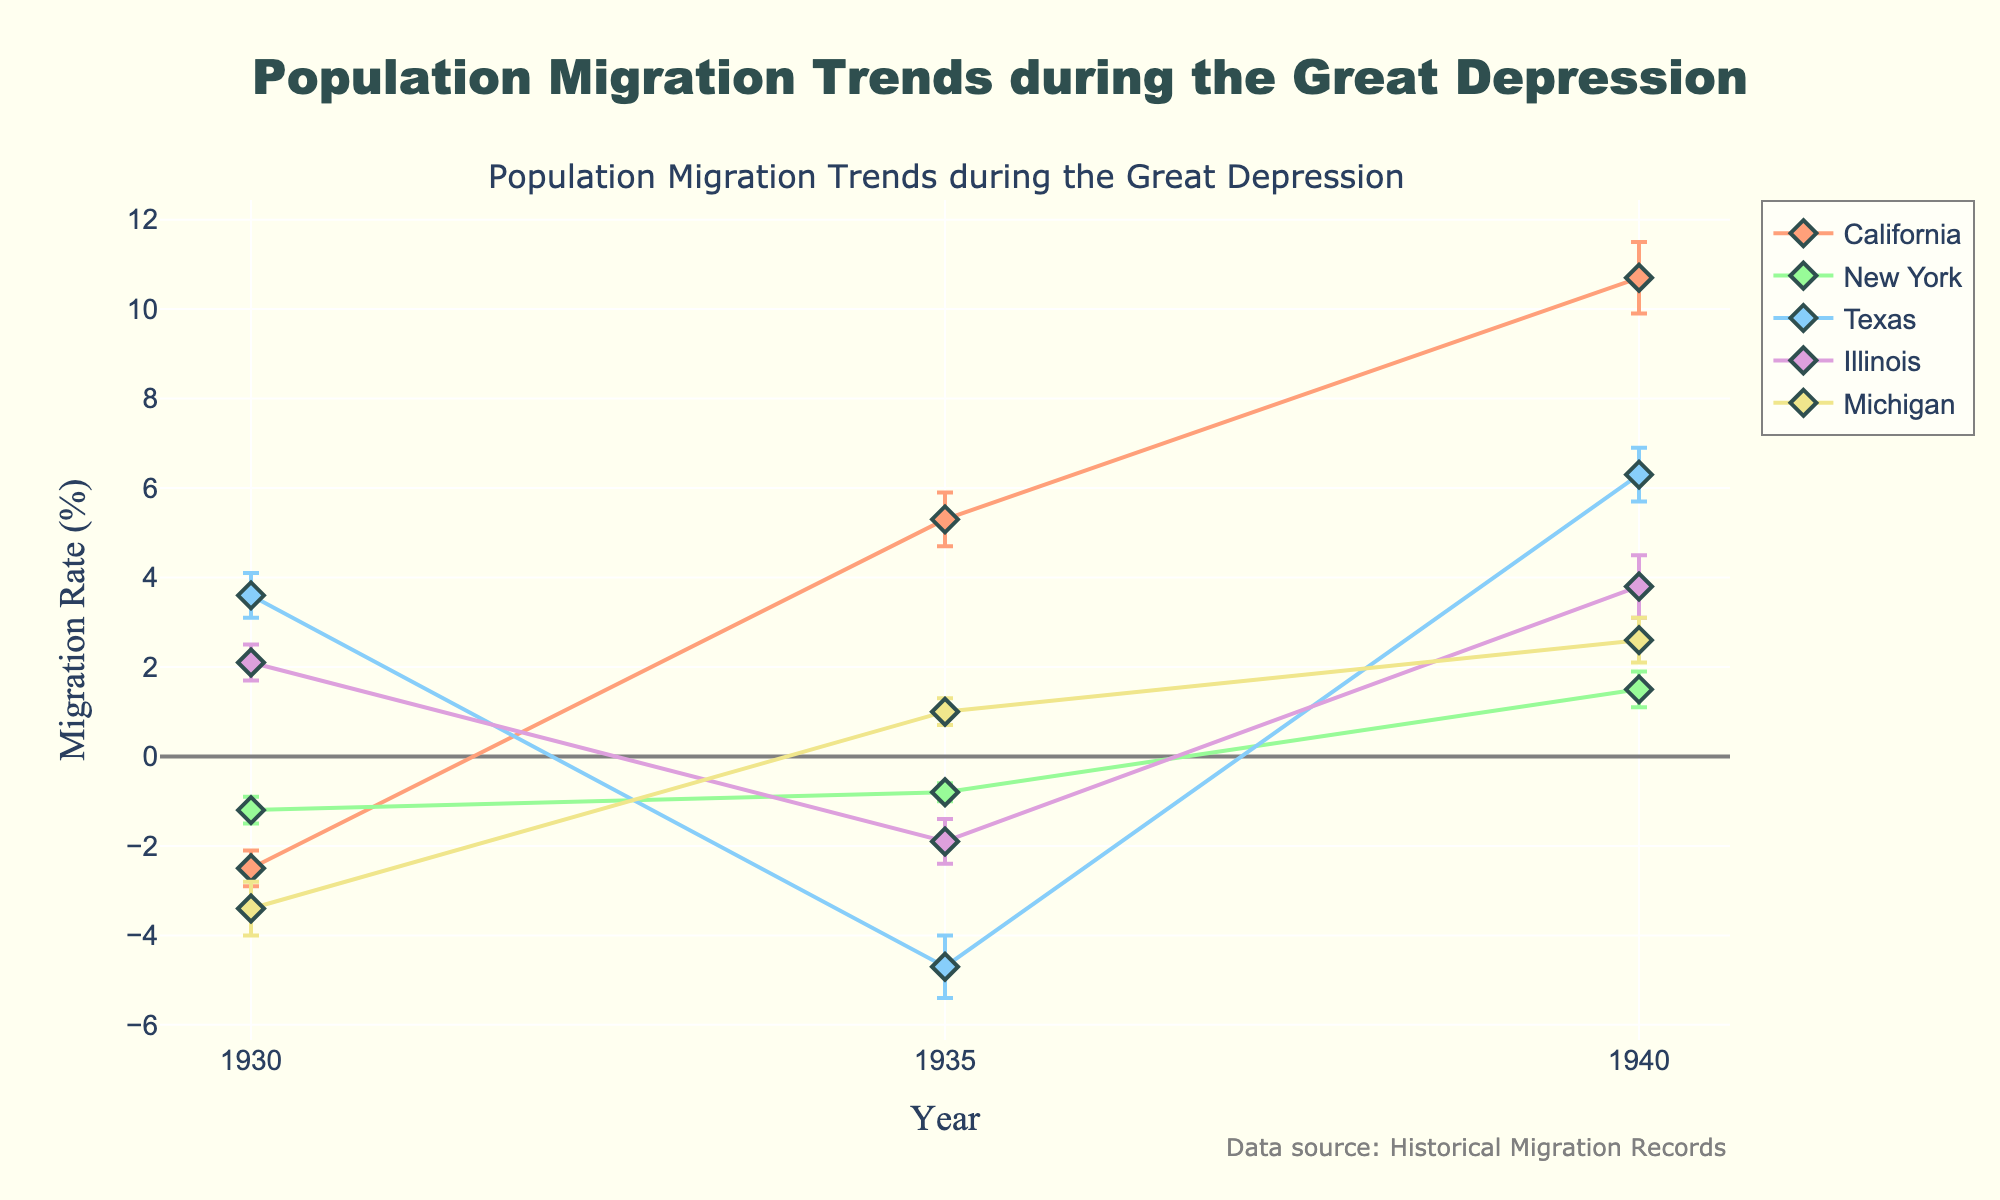What is the title of the plot? Look at the top of the plot, where the title is typically placed. It reads: 'Population Migration Trends during the Great Depression'
Answer: Population Migration Trends during the Great Depression What regions are represented in the plot? Identify the different lines and check the legend that lists the names of the regions. The regions are California, New York, Texas, Illinois, and Michigan.
Answer: California, New York, Texas, Illinois, Michigan What is the migration rate for California in 1935? Locate the point for California in 1935 on the x-axis and check the corresponding y-axis value. The migration rate for California in 1935 is 5.3%.
Answer: 5.3% How did the migration rate of Texas change from 1935 to 1940? Compare the migration rates of Texas in 1935 and 1940. In 1935, it was -4.7%. In 1940, it increased to 6.3%. The change is 6.3% - (-4.7%) which is 11%.
Answer: Increased by 11% Which region had the highest migration rate in 1940? Compare the migration rates for all regions in 1940 shown in the plot. California had the highest migration rate of 10.7%.
Answer: California Between 1930 and 1935, in which region did the migration rate decrease the most? Calculate the difference in migration rates between 1930 and 1935 for each region. Texas had the largest decrease from 3.6% to -4.7%, which is a decrease of 8.3%.
Answer: Texas What is the range of the migration rates for Illinois during the plotted years? Identify the lowest and highest migration rates for Illinois. The lowest is -1.9% in 1935 and the highest is 3.8% in 1940, so the range is 3.8% - (-1.9%) = 5.7%.
Answer: 5.7% How can you describe the general trend of migration for Michigan based on the plot? Observe the points for Michigan at 1930, 1935, and 1940. The migration rate increased over time from -3.4% in 1930, to 1.0% in 1935, and then to 2.6% in 1940.
Answer: Increasing trend Which region's migration rate had the most variability over the years? Compare the variability (shown by the error bars' lengths) for all regions. California's error bars (0.4, 0.6, 0.8) appear to show the most consistent and substantial variability across the years.
Answer: California What might be a reason for including error bars in this plot? Error bars indicate the variability or uncertainty in the migration rate data, providing insight into how precise the measurements are. This helps the viewer understand the reliability of the data points shown.
Answer: To indicate data variability and measurement precision 